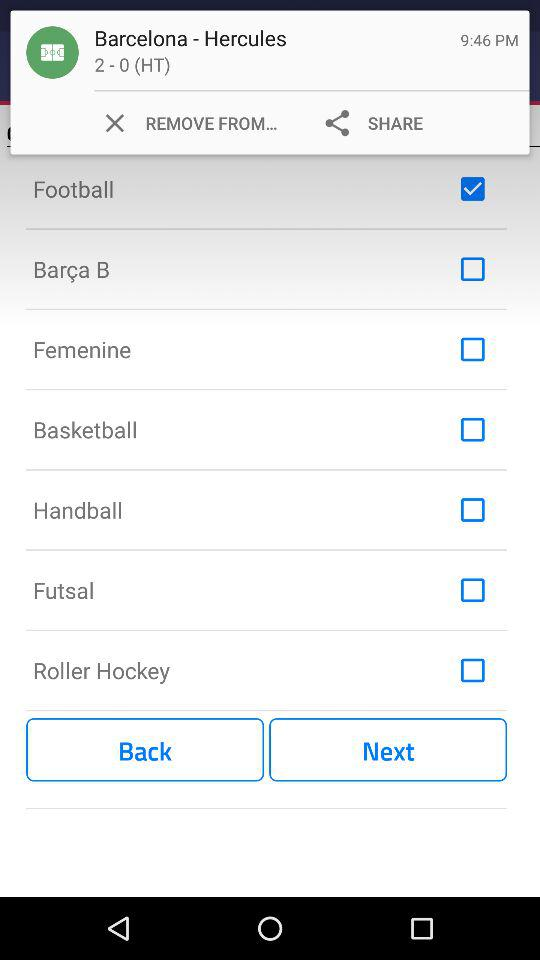What is the time? The time is 9:46 pm. 